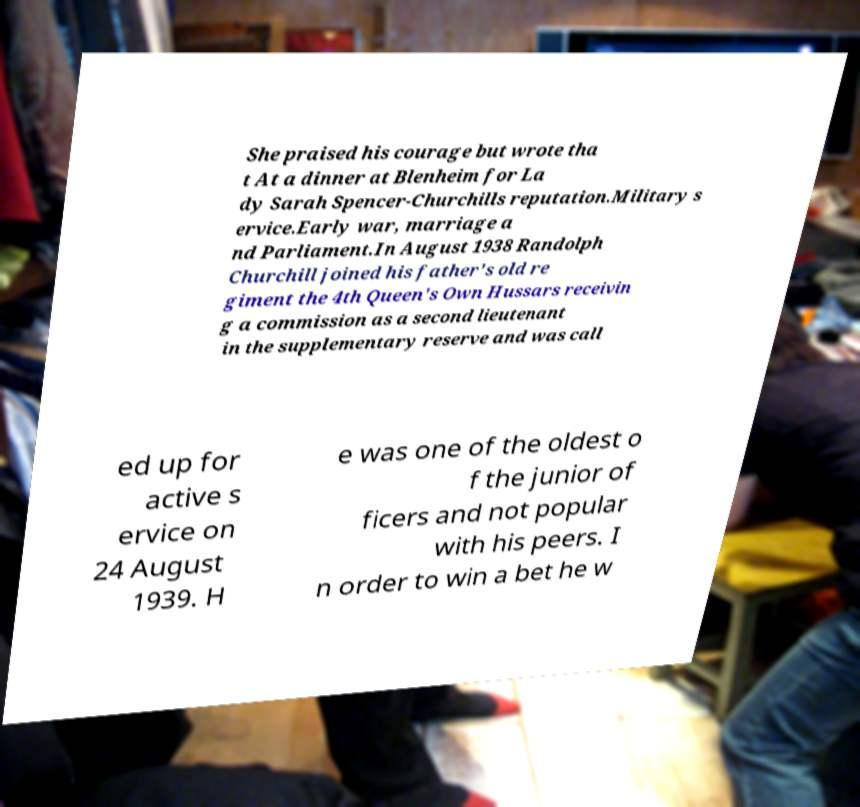What messages or text are displayed in this image? I need them in a readable, typed format. She praised his courage but wrote tha t At a dinner at Blenheim for La dy Sarah Spencer-Churchills reputation.Military s ervice.Early war, marriage a nd Parliament.In August 1938 Randolph Churchill joined his father's old re giment the 4th Queen's Own Hussars receivin g a commission as a second lieutenant in the supplementary reserve and was call ed up for active s ervice on 24 August 1939. H e was one of the oldest o f the junior of ficers and not popular with his peers. I n order to win a bet he w 